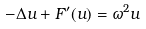Convert formula to latex. <formula><loc_0><loc_0><loc_500><loc_500>- \Delta u + F ^ { \prime } ( u ) = \omega ^ { 2 } u</formula> 